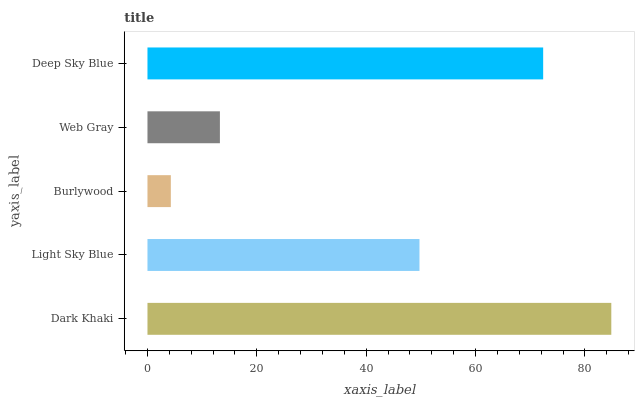Is Burlywood the minimum?
Answer yes or no. Yes. Is Dark Khaki the maximum?
Answer yes or no. Yes. Is Light Sky Blue the minimum?
Answer yes or no. No. Is Light Sky Blue the maximum?
Answer yes or no. No. Is Dark Khaki greater than Light Sky Blue?
Answer yes or no. Yes. Is Light Sky Blue less than Dark Khaki?
Answer yes or no. Yes. Is Light Sky Blue greater than Dark Khaki?
Answer yes or no. No. Is Dark Khaki less than Light Sky Blue?
Answer yes or no. No. Is Light Sky Blue the high median?
Answer yes or no. Yes. Is Light Sky Blue the low median?
Answer yes or no. Yes. Is Dark Khaki the high median?
Answer yes or no. No. Is Web Gray the low median?
Answer yes or no. No. 